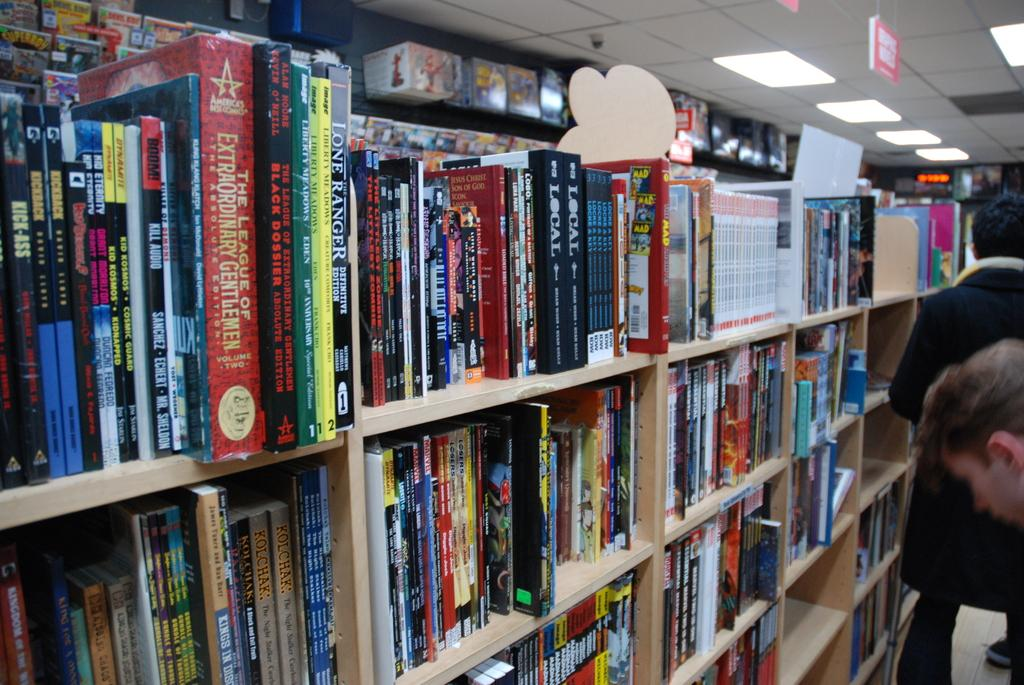<image>
Summarize the visual content of the image. A book called Ranger sits on a shelf with other books. 